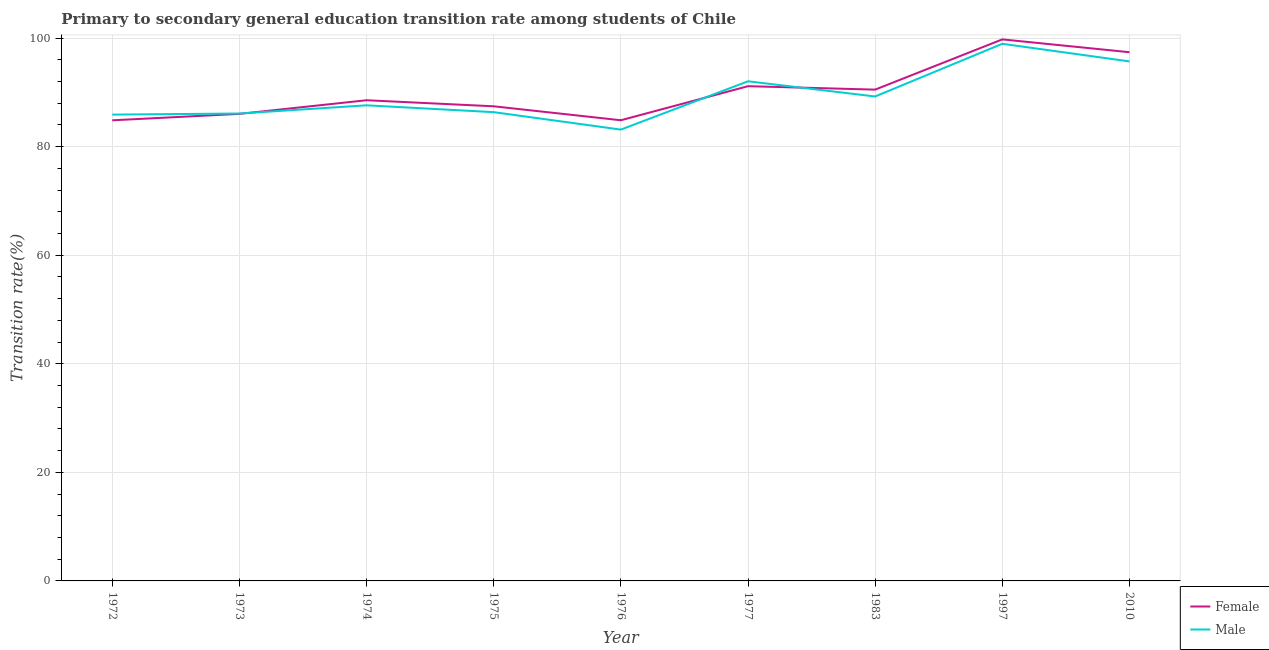How many different coloured lines are there?
Keep it short and to the point. 2. What is the transition rate among female students in 1976?
Offer a very short reply. 84.86. Across all years, what is the maximum transition rate among male students?
Your answer should be compact. 98.94. Across all years, what is the minimum transition rate among male students?
Keep it short and to the point. 83.13. In which year was the transition rate among female students minimum?
Your answer should be compact. 1972. What is the total transition rate among female students in the graph?
Give a very brief answer. 810.47. What is the difference between the transition rate among male students in 1972 and that in 1974?
Your answer should be very brief. -1.71. What is the difference between the transition rate among male students in 1997 and the transition rate among female students in 2010?
Keep it short and to the point. 1.55. What is the average transition rate among female students per year?
Make the answer very short. 90.05. In the year 1976, what is the difference between the transition rate among female students and transition rate among male students?
Offer a very short reply. 1.72. In how many years, is the transition rate among female students greater than 88 %?
Keep it short and to the point. 5. What is the ratio of the transition rate among female students in 1973 to that in 1975?
Offer a terse response. 0.98. Is the transition rate among female students in 1972 less than that in 1997?
Your response must be concise. Yes. What is the difference between the highest and the second highest transition rate among female students?
Provide a short and direct response. 2.36. What is the difference between the highest and the lowest transition rate among female students?
Make the answer very short. 14.91. In how many years, is the transition rate among male students greater than the average transition rate among male students taken over all years?
Your answer should be very brief. 3. Is the sum of the transition rate among female students in 1976 and 1977 greater than the maximum transition rate among male students across all years?
Offer a very short reply. Yes. Does the transition rate among female students monotonically increase over the years?
Ensure brevity in your answer.  No. Is the transition rate among male students strictly greater than the transition rate among female students over the years?
Offer a very short reply. No. Are the values on the major ticks of Y-axis written in scientific E-notation?
Provide a short and direct response. No. What is the title of the graph?
Offer a very short reply. Primary to secondary general education transition rate among students of Chile. What is the label or title of the X-axis?
Your response must be concise. Year. What is the label or title of the Y-axis?
Offer a terse response. Transition rate(%). What is the Transition rate(%) of Female in 1972?
Offer a very short reply. 84.85. What is the Transition rate(%) of Male in 1972?
Offer a very short reply. 85.89. What is the Transition rate(%) of Female in 1973?
Ensure brevity in your answer.  86.03. What is the Transition rate(%) of Male in 1973?
Your answer should be compact. 86.1. What is the Transition rate(%) of Female in 1974?
Your answer should be very brief. 88.54. What is the Transition rate(%) of Male in 1974?
Keep it short and to the point. 87.61. What is the Transition rate(%) of Female in 1975?
Offer a very short reply. 87.43. What is the Transition rate(%) of Male in 1975?
Your response must be concise. 86.35. What is the Transition rate(%) of Female in 1976?
Offer a very short reply. 84.86. What is the Transition rate(%) of Male in 1976?
Make the answer very short. 83.13. What is the Transition rate(%) of Female in 1977?
Give a very brief answer. 91.13. What is the Transition rate(%) in Male in 1977?
Give a very brief answer. 92.03. What is the Transition rate(%) of Female in 1983?
Give a very brief answer. 90.5. What is the Transition rate(%) in Male in 1983?
Ensure brevity in your answer.  89.24. What is the Transition rate(%) in Female in 1997?
Keep it short and to the point. 99.75. What is the Transition rate(%) of Male in 1997?
Offer a very short reply. 98.94. What is the Transition rate(%) of Female in 2010?
Keep it short and to the point. 97.39. What is the Transition rate(%) in Male in 2010?
Your answer should be very brief. 95.69. Across all years, what is the maximum Transition rate(%) of Female?
Your response must be concise. 99.75. Across all years, what is the maximum Transition rate(%) in Male?
Your answer should be compact. 98.94. Across all years, what is the minimum Transition rate(%) of Female?
Provide a short and direct response. 84.85. Across all years, what is the minimum Transition rate(%) of Male?
Your response must be concise. 83.13. What is the total Transition rate(%) of Female in the graph?
Offer a very short reply. 810.47. What is the total Transition rate(%) of Male in the graph?
Keep it short and to the point. 804.98. What is the difference between the Transition rate(%) in Female in 1972 and that in 1973?
Your response must be concise. -1.18. What is the difference between the Transition rate(%) in Male in 1972 and that in 1973?
Provide a succinct answer. -0.2. What is the difference between the Transition rate(%) in Female in 1972 and that in 1974?
Provide a succinct answer. -3.7. What is the difference between the Transition rate(%) of Male in 1972 and that in 1974?
Your answer should be very brief. -1.71. What is the difference between the Transition rate(%) in Female in 1972 and that in 1975?
Provide a succinct answer. -2.58. What is the difference between the Transition rate(%) in Male in 1972 and that in 1975?
Keep it short and to the point. -0.45. What is the difference between the Transition rate(%) in Female in 1972 and that in 1976?
Provide a succinct answer. -0.01. What is the difference between the Transition rate(%) in Male in 1972 and that in 1976?
Make the answer very short. 2.76. What is the difference between the Transition rate(%) in Female in 1972 and that in 1977?
Give a very brief answer. -6.28. What is the difference between the Transition rate(%) in Male in 1972 and that in 1977?
Your answer should be very brief. -6.14. What is the difference between the Transition rate(%) in Female in 1972 and that in 1983?
Keep it short and to the point. -5.65. What is the difference between the Transition rate(%) of Male in 1972 and that in 1983?
Provide a short and direct response. -3.34. What is the difference between the Transition rate(%) of Female in 1972 and that in 1997?
Your answer should be compact. -14.91. What is the difference between the Transition rate(%) of Male in 1972 and that in 1997?
Give a very brief answer. -13.05. What is the difference between the Transition rate(%) in Female in 1972 and that in 2010?
Provide a short and direct response. -12.54. What is the difference between the Transition rate(%) in Male in 1972 and that in 2010?
Ensure brevity in your answer.  -9.8. What is the difference between the Transition rate(%) in Female in 1973 and that in 1974?
Your answer should be compact. -2.51. What is the difference between the Transition rate(%) of Male in 1973 and that in 1974?
Ensure brevity in your answer.  -1.51. What is the difference between the Transition rate(%) in Female in 1973 and that in 1975?
Your answer should be very brief. -1.4. What is the difference between the Transition rate(%) in Male in 1973 and that in 1975?
Offer a very short reply. -0.25. What is the difference between the Transition rate(%) in Female in 1973 and that in 1976?
Ensure brevity in your answer.  1.17. What is the difference between the Transition rate(%) in Male in 1973 and that in 1976?
Ensure brevity in your answer.  2.96. What is the difference between the Transition rate(%) in Female in 1973 and that in 1977?
Your answer should be very brief. -5.1. What is the difference between the Transition rate(%) in Male in 1973 and that in 1977?
Ensure brevity in your answer.  -5.94. What is the difference between the Transition rate(%) in Female in 1973 and that in 1983?
Give a very brief answer. -4.47. What is the difference between the Transition rate(%) in Male in 1973 and that in 1983?
Provide a short and direct response. -3.14. What is the difference between the Transition rate(%) in Female in 1973 and that in 1997?
Give a very brief answer. -13.72. What is the difference between the Transition rate(%) in Male in 1973 and that in 1997?
Offer a very short reply. -12.84. What is the difference between the Transition rate(%) in Female in 1973 and that in 2010?
Provide a short and direct response. -11.36. What is the difference between the Transition rate(%) of Male in 1973 and that in 2010?
Your answer should be very brief. -9.6. What is the difference between the Transition rate(%) of Female in 1974 and that in 1975?
Offer a very short reply. 1.12. What is the difference between the Transition rate(%) of Male in 1974 and that in 1975?
Ensure brevity in your answer.  1.26. What is the difference between the Transition rate(%) in Female in 1974 and that in 1976?
Your answer should be compact. 3.69. What is the difference between the Transition rate(%) of Male in 1974 and that in 1976?
Provide a succinct answer. 4.47. What is the difference between the Transition rate(%) of Female in 1974 and that in 1977?
Ensure brevity in your answer.  -2.59. What is the difference between the Transition rate(%) of Male in 1974 and that in 1977?
Provide a short and direct response. -4.42. What is the difference between the Transition rate(%) in Female in 1974 and that in 1983?
Keep it short and to the point. -1.96. What is the difference between the Transition rate(%) of Male in 1974 and that in 1983?
Offer a very short reply. -1.63. What is the difference between the Transition rate(%) in Female in 1974 and that in 1997?
Your response must be concise. -11.21. What is the difference between the Transition rate(%) in Male in 1974 and that in 1997?
Your response must be concise. -11.33. What is the difference between the Transition rate(%) of Female in 1974 and that in 2010?
Your answer should be very brief. -8.85. What is the difference between the Transition rate(%) of Male in 1974 and that in 2010?
Make the answer very short. -8.09. What is the difference between the Transition rate(%) in Female in 1975 and that in 1976?
Ensure brevity in your answer.  2.57. What is the difference between the Transition rate(%) in Male in 1975 and that in 1976?
Your answer should be compact. 3.21. What is the difference between the Transition rate(%) in Female in 1975 and that in 1977?
Keep it short and to the point. -3.7. What is the difference between the Transition rate(%) in Male in 1975 and that in 1977?
Your answer should be compact. -5.68. What is the difference between the Transition rate(%) of Female in 1975 and that in 1983?
Provide a short and direct response. -3.07. What is the difference between the Transition rate(%) in Male in 1975 and that in 1983?
Ensure brevity in your answer.  -2.89. What is the difference between the Transition rate(%) of Female in 1975 and that in 1997?
Give a very brief answer. -12.32. What is the difference between the Transition rate(%) in Male in 1975 and that in 1997?
Make the answer very short. -12.59. What is the difference between the Transition rate(%) of Female in 1975 and that in 2010?
Your response must be concise. -9.96. What is the difference between the Transition rate(%) of Male in 1975 and that in 2010?
Ensure brevity in your answer.  -9.35. What is the difference between the Transition rate(%) of Female in 1976 and that in 1977?
Your answer should be very brief. -6.27. What is the difference between the Transition rate(%) in Male in 1976 and that in 1977?
Give a very brief answer. -8.9. What is the difference between the Transition rate(%) in Female in 1976 and that in 1983?
Offer a very short reply. -5.64. What is the difference between the Transition rate(%) of Male in 1976 and that in 1983?
Your answer should be compact. -6.1. What is the difference between the Transition rate(%) in Female in 1976 and that in 1997?
Offer a terse response. -14.9. What is the difference between the Transition rate(%) of Male in 1976 and that in 1997?
Offer a very short reply. -15.81. What is the difference between the Transition rate(%) of Female in 1976 and that in 2010?
Your answer should be compact. -12.53. What is the difference between the Transition rate(%) of Male in 1976 and that in 2010?
Your response must be concise. -12.56. What is the difference between the Transition rate(%) of Female in 1977 and that in 1983?
Offer a terse response. 0.63. What is the difference between the Transition rate(%) in Male in 1977 and that in 1983?
Offer a terse response. 2.8. What is the difference between the Transition rate(%) in Female in 1977 and that in 1997?
Make the answer very short. -8.62. What is the difference between the Transition rate(%) of Male in 1977 and that in 1997?
Your response must be concise. -6.91. What is the difference between the Transition rate(%) in Female in 1977 and that in 2010?
Make the answer very short. -6.26. What is the difference between the Transition rate(%) of Male in 1977 and that in 2010?
Make the answer very short. -3.66. What is the difference between the Transition rate(%) in Female in 1983 and that in 1997?
Your answer should be very brief. -9.25. What is the difference between the Transition rate(%) of Male in 1983 and that in 1997?
Keep it short and to the point. -9.71. What is the difference between the Transition rate(%) in Female in 1983 and that in 2010?
Make the answer very short. -6.89. What is the difference between the Transition rate(%) in Male in 1983 and that in 2010?
Offer a terse response. -6.46. What is the difference between the Transition rate(%) in Female in 1997 and that in 2010?
Offer a very short reply. 2.36. What is the difference between the Transition rate(%) of Male in 1997 and that in 2010?
Ensure brevity in your answer.  3.25. What is the difference between the Transition rate(%) in Female in 1972 and the Transition rate(%) in Male in 1973?
Your response must be concise. -1.25. What is the difference between the Transition rate(%) in Female in 1972 and the Transition rate(%) in Male in 1974?
Your response must be concise. -2.76. What is the difference between the Transition rate(%) in Female in 1972 and the Transition rate(%) in Male in 1975?
Keep it short and to the point. -1.5. What is the difference between the Transition rate(%) in Female in 1972 and the Transition rate(%) in Male in 1976?
Keep it short and to the point. 1.71. What is the difference between the Transition rate(%) of Female in 1972 and the Transition rate(%) of Male in 1977?
Make the answer very short. -7.19. What is the difference between the Transition rate(%) in Female in 1972 and the Transition rate(%) in Male in 1983?
Provide a succinct answer. -4.39. What is the difference between the Transition rate(%) of Female in 1972 and the Transition rate(%) of Male in 1997?
Provide a succinct answer. -14.09. What is the difference between the Transition rate(%) in Female in 1972 and the Transition rate(%) in Male in 2010?
Your answer should be compact. -10.85. What is the difference between the Transition rate(%) of Female in 1973 and the Transition rate(%) of Male in 1974?
Offer a very short reply. -1.58. What is the difference between the Transition rate(%) of Female in 1973 and the Transition rate(%) of Male in 1975?
Offer a very short reply. -0.32. What is the difference between the Transition rate(%) in Female in 1973 and the Transition rate(%) in Male in 1976?
Give a very brief answer. 2.89. What is the difference between the Transition rate(%) in Female in 1973 and the Transition rate(%) in Male in 1977?
Keep it short and to the point. -6. What is the difference between the Transition rate(%) of Female in 1973 and the Transition rate(%) of Male in 1983?
Your answer should be very brief. -3.21. What is the difference between the Transition rate(%) in Female in 1973 and the Transition rate(%) in Male in 1997?
Provide a short and direct response. -12.91. What is the difference between the Transition rate(%) in Female in 1973 and the Transition rate(%) in Male in 2010?
Your answer should be compact. -9.66. What is the difference between the Transition rate(%) in Female in 1974 and the Transition rate(%) in Male in 1975?
Offer a terse response. 2.19. What is the difference between the Transition rate(%) in Female in 1974 and the Transition rate(%) in Male in 1976?
Make the answer very short. 5.41. What is the difference between the Transition rate(%) of Female in 1974 and the Transition rate(%) of Male in 1977?
Your response must be concise. -3.49. What is the difference between the Transition rate(%) in Female in 1974 and the Transition rate(%) in Male in 1983?
Your answer should be very brief. -0.69. What is the difference between the Transition rate(%) in Female in 1974 and the Transition rate(%) in Male in 1997?
Provide a short and direct response. -10.4. What is the difference between the Transition rate(%) in Female in 1974 and the Transition rate(%) in Male in 2010?
Make the answer very short. -7.15. What is the difference between the Transition rate(%) of Female in 1975 and the Transition rate(%) of Male in 1976?
Ensure brevity in your answer.  4.29. What is the difference between the Transition rate(%) in Female in 1975 and the Transition rate(%) in Male in 1977?
Offer a very short reply. -4.61. What is the difference between the Transition rate(%) in Female in 1975 and the Transition rate(%) in Male in 1983?
Provide a succinct answer. -1.81. What is the difference between the Transition rate(%) of Female in 1975 and the Transition rate(%) of Male in 1997?
Keep it short and to the point. -11.51. What is the difference between the Transition rate(%) of Female in 1975 and the Transition rate(%) of Male in 2010?
Offer a terse response. -8.27. What is the difference between the Transition rate(%) of Female in 1976 and the Transition rate(%) of Male in 1977?
Provide a short and direct response. -7.18. What is the difference between the Transition rate(%) of Female in 1976 and the Transition rate(%) of Male in 1983?
Your response must be concise. -4.38. What is the difference between the Transition rate(%) of Female in 1976 and the Transition rate(%) of Male in 1997?
Make the answer very short. -14.08. What is the difference between the Transition rate(%) of Female in 1976 and the Transition rate(%) of Male in 2010?
Provide a short and direct response. -10.84. What is the difference between the Transition rate(%) in Female in 1977 and the Transition rate(%) in Male in 1983?
Offer a terse response. 1.89. What is the difference between the Transition rate(%) of Female in 1977 and the Transition rate(%) of Male in 1997?
Your response must be concise. -7.81. What is the difference between the Transition rate(%) of Female in 1977 and the Transition rate(%) of Male in 2010?
Provide a succinct answer. -4.56. What is the difference between the Transition rate(%) of Female in 1983 and the Transition rate(%) of Male in 1997?
Make the answer very short. -8.44. What is the difference between the Transition rate(%) of Female in 1983 and the Transition rate(%) of Male in 2010?
Offer a very short reply. -5.2. What is the difference between the Transition rate(%) in Female in 1997 and the Transition rate(%) in Male in 2010?
Keep it short and to the point. 4.06. What is the average Transition rate(%) in Female per year?
Offer a terse response. 90.05. What is the average Transition rate(%) of Male per year?
Provide a succinct answer. 89.44. In the year 1972, what is the difference between the Transition rate(%) in Female and Transition rate(%) in Male?
Your answer should be compact. -1.05. In the year 1973, what is the difference between the Transition rate(%) of Female and Transition rate(%) of Male?
Provide a short and direct response. -0.07. In the year 1974, what is the difference between the Transition rate(%) of Female and Transition rate(%) of Male?
Give a very brief answer. 0.93. In the year 1975, what is the difference between the Transition rate(%) in Female and Transition rate(%) in Male?
Provide a succinct answer. 1.08. In the year 1976, what is the difference between the Transition rate(%) of Female and Transition rate(%) of Male?
Give a very brief answer. 1.72. In the year 1977, what is the difference between the Transition rate(%) in Female and Transition rate(%) in Male?
Offer a terse response. -0.9. In the year 1983, what is the difference between the Transition rate(%) of Female and Transition rate(%) of Male?
Provide a succinct answer. 1.26. In the year 1997, what is the difference between the Transition rate(%) in Female and Transition rate(%) in Male?
Make the answer very short. 0.81. In the year 2010, what is the difference between the Transition rate(%) of Female and Transition rate(%) of Male?
Your answer should be compact. 1.69. What is the ratio of the Transition rate(%) in Female in 1972 to that in 1973?
Your answer should be compact. 0.99. What is the ratio of the Transition rate(%) of Male in 1972 to that in 1973?
Provide a succinct answer. 1. What is the ratio of the Transition rate(%) of Male in 1972 to that in 1974?
Give a very brief answer. 0.98. What is the ratio of the Transition rate(%) in Female in 1972 to that in 1975?
Offer a very short reply. 0.97. What is the ratio of the Transition rate(%) of Male in 1972 to that in 1975?
Provide a short and direct response. 0.99. What is the ratio of the Transition rate(%) of Female in 1972 to that in 1976?
Offer a terse response. 1. What is the ratio of the Transition rate(%) in Male in 1972 to that in 1976?
Make the answer very short. 1.03. What is the ratio of the Transition rate(%) of Male in 1972 to that in 1977?
Offer a terse response. 0.93. What is the ratio of the Transition rate(%) of Male in 1972 to that in 1983?
Ensure brevity in your answer.  0.96. What is the ratio of the Transition rate(%) of Female in 1972 to that in 1997?
Provide a succinct answer. 0.85. What is the ratio of the Transition rate(%) of Male in 1972 to that in 1997?
Your answer should be very brief. 0.87. What is the ratio of the Transition rate(%) in Female in 1972 to that in 2010?
Make the answer very short. 0.87. What is the ratio of the Transition rate(%) in Male in 1972 to that in 2010?
Keep it short and to the point. 0.9. What is the ratio of the Transition rate(%) in Female in 1973 to that in 1974?
Give a very brief answer. 0.97. What is the ratio of the Transition rate(%) of Male in 1973 to that in 1974?
Offer a very short reply. 0.98. What is the ratio of the Transition rate(%) of Female in 1973 to that in 1975?
Offer a very short reply. 0.98. What is the ratio of the Transition rate(%) in Female in 1973 to that in 1976?
Your answer should be very brief. 1.01. What is the ratio of the Transition rate(%) of Male in 1973 to that in 1976?
Offer a very short reply. 1.04. What is the ratio of the Transition rate(%) in Female in 1973 to that in 1977?
Offer a terse response. 0.94. What is the ratio of the Transition rate(%) in Male in 1973 to that in 1977?
Ensure brevity in your answer.  0.94. What is the ratio of the Transition rate(%) in Female in 1973 to that in 1983?
Offer a terse response. 0.95. What is the ratio of the Transition rate(%) of Male in 1973 to that in 1983?
Ensure brevity in your answer.  0.96. What is the ratio of the Transition rate(%) of Female in 1973 to that in 1997?
Offer a very short reply. 0.86. What is the ratio of the Transition rate(%) of Male in 1973 to that in 1997?
Make the answer very short. 0.87. What is the ratio of the Transition rate(%) of Female in 1973 to that in 2010?
Give a very brief answer. 0.88. What is the ratio of the Transition rate(%) of Male in 1973 to that in 2010?
Your answer should be very brief. 0.9. What is the ratio of the Transition rate(%) in Female in 1974 to that in 1975?
Provide a short and direct response. 1.01. What is the ratio of the Transition rate(%) of Male in 1974 to that in 1975?
Offer a very short reply. 1.01. What is the ratio of the Transition rate(%) in Female in 1974 to that in 1976?
Make the answer very short. 1.04. What is the ratio of the Transition rate(%) of Male in 1974 to that in 1976?
Offer a very short reply. 1.05. What is the ratio of the Transition rate(%) of Female in 1974 to that in 1977?
Ensure brevity in your answer.  0.97. What is the ratio of the Transition rate(%) in Male in 1974 to that in 1977?
Offer a very short reply. 0.95. What is the ratio of the Transition rate(%) of Female in 1974 to that in 1983?
Keep it short and to the point. 0.98. What is the ratio of the Transition rate(%) in Male in 1974 to that in 1983?
Ensure brevity in your answer.  0.98. What is the ratio of the Transition rate(%) of Female in 1974 to that in 1997?
Provide a succinct answer. 0.89. What is the ratio of the Transition rate(%) of Male in 1974 to that in 1997?
Provide a short and direct response. 0.89. What is the ratio of the Transition rate(%) of Female in 1974 to that in 2010?
Offer a very short reply. 0.91. What is the ratio of the Transition rate(%) in Male in 1974 to that in 2010?
Your answer should be compact. 0.92. What is the ratio of the Transition rate(%) of Female in 1975 to that in 1976?
Your answer should be compact. 1.03. What is the ratio of the Transition rate(%) in Male in 1975 to that in 1976?
Make the answer very short. 1.04. What is the ratio of the Transition rate(%) in Female in 1975 to that in 1977?
Ensure brevity in your answer.  0.96. What is the ratio of the Transition rate(%) of Male in 1975 to that in 1977?
Provide a short and direct response. 0.94. What is the ratio of the Transition rate(%) of Female in 1975 to that in 1983?
Keep it short and to the point. 0.97. What is the ratio of the Transition rate(%) in Male in 1975 to that in 1983?
Offer a terse response. 0.97. What is the ratio of the Transition rate(%) of Female in 1975 to that in 1997?
Ensure brevity in your answer.  0.88. What is the ratio of the Transition rate(%) in Male in 1975 to that in 1997?
Keep it short and to the point. 0.87. What is the ratio of the Transition rate(%) of Female in 1975 to that in 2010?
Provide a short and direct response. 0.9. What is the ratio of the Transition rate(%) of Male in 1975 to that in 2010?
Keep it short and to the point. 0.9. What is the ratio of the Transition rate(%) in Female in 1976 to that in 1977?
Your response must be concise. 0.93. What is the ratio of the Transition rate(%) in Male in 1976 to that in 1977?
Offer a terse response. 0.9. What is the ratio of the Transition rate(%) of Female in 1976 to that in 1983?
Offer a very short reply. 0.94. What is the ratio of the Transition rate(%) in Male in 1976 to that in 1983?
Ensure brevity in your answer.  0.93. What is the ratio of the Transition rate(%) in Female in 1976 to that in 1997?
Give a very brief answer. 0.85. What is the ratio of the Transition rate(%) in Male in 1976 to that in 1997?
Make the answer very short. 0.84. What is the ratio of the Transition rate(%) of Female in 1976 to that in 2010?
Offer a very short reply. 0.87. What is the ratio of the Transition rate(%) of Male in 1976 to that in 2010?
Your response must be concise. 0.87. What is the ratio of the Transition rate(%) of Male in 1977 to that in 1983?
Your answer should be compact. 1.03. What is the ratio of the Transition rate(%) in Female in 1977 to that in 1997?
Offer a very short reply. 0.91. What is the ratio of the Transition rate(%) of Male in 1977 to that in 1997?
Your response must be concise. 0.93. What is the ratio of the Transition rate(%) in Female in 1977 to that in 2010?
Your response must be concise. 0.94. What is the ratio of the Transition rate(%) in Male in 1977 to that in 2010?
Give a very brief answer. 0.96. What is the ratio of the Transition rate(%) in Female in 1983 to that in 1997?
Offer a very short reply. 0.91. What is the ratio of the Transition rate(%) in Male in 1983 to that in 1997?
Ensure brevity in your answer.  0.9. What is the ratio of the Transition rate(%) of Female in 1983 to that in 2010?
Offer a very short reply. 0.93. What is the ratio of the Transition rate(%) of Male in 1983 to that in 2010?
Provide a short and direct response. 0.93. What is the ratio of the Transition rate(%) in Female in 1997 to that in 2010?
Your response must be concise. 1.02. What is the ratio of the Transition rate(%) in Male in 1997 to that in 2010?
Offer a very short reply. 1.03. What is the difference between the highest and the second highest Transition rate(%) in Female?
Provide a short and direct response. 2.36. What is the difference between the highest and the second highest Transition rate(%) of Male?
Give a very brief answer. 3.25. What is the difference between the highest and the lowest Transition rate(%) in Female?
Provide a short and direct response. 14.91. What is the difference between the highest and the lowest Transition rate(%) of Male?
Your answer should be very brief. 15.81. 